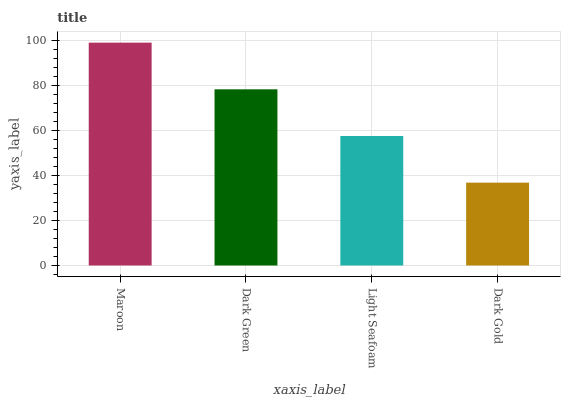Is Dark Gold the minimum?
Answer yes or no. Yes. Is Maroon the maximum?
Answer yes or no. Yes. Is Dark Green the minimum?
Answer yes or no. No. Is Dark Green the maximum?
Answer yes or no. No. Is Maroon greater than Dark Green?
Answer yes or no. Yes. Is Dark Green less than Maroon?
Answer yes or no. Yes. Is Dark Green greater than Maroon?
Answer yes or no. No. Is Maroon less than Dark Green?
Answer yes or no. No. Is Dark Green the high median?
Answer yes or no. Yes. Is Light Seafoam the low median?
Answer yes or no. Yes. Is Light Seafoam the high median?
Answer yes or no. No. Is Maroon the low median?
Answer yes or no. No. 